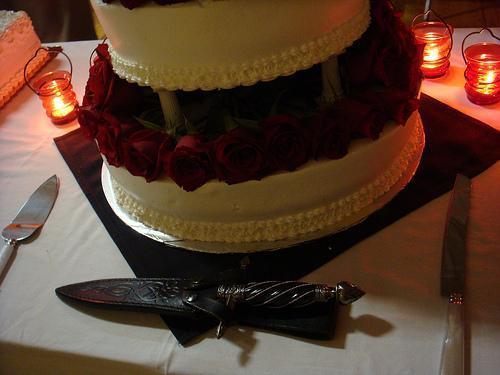How many knives are shown?
Give a very brief answer. 3. How many candles are shown?
Give a very brief answer. 3. How many candles are on the table?
Give a very brief answer. 3. 